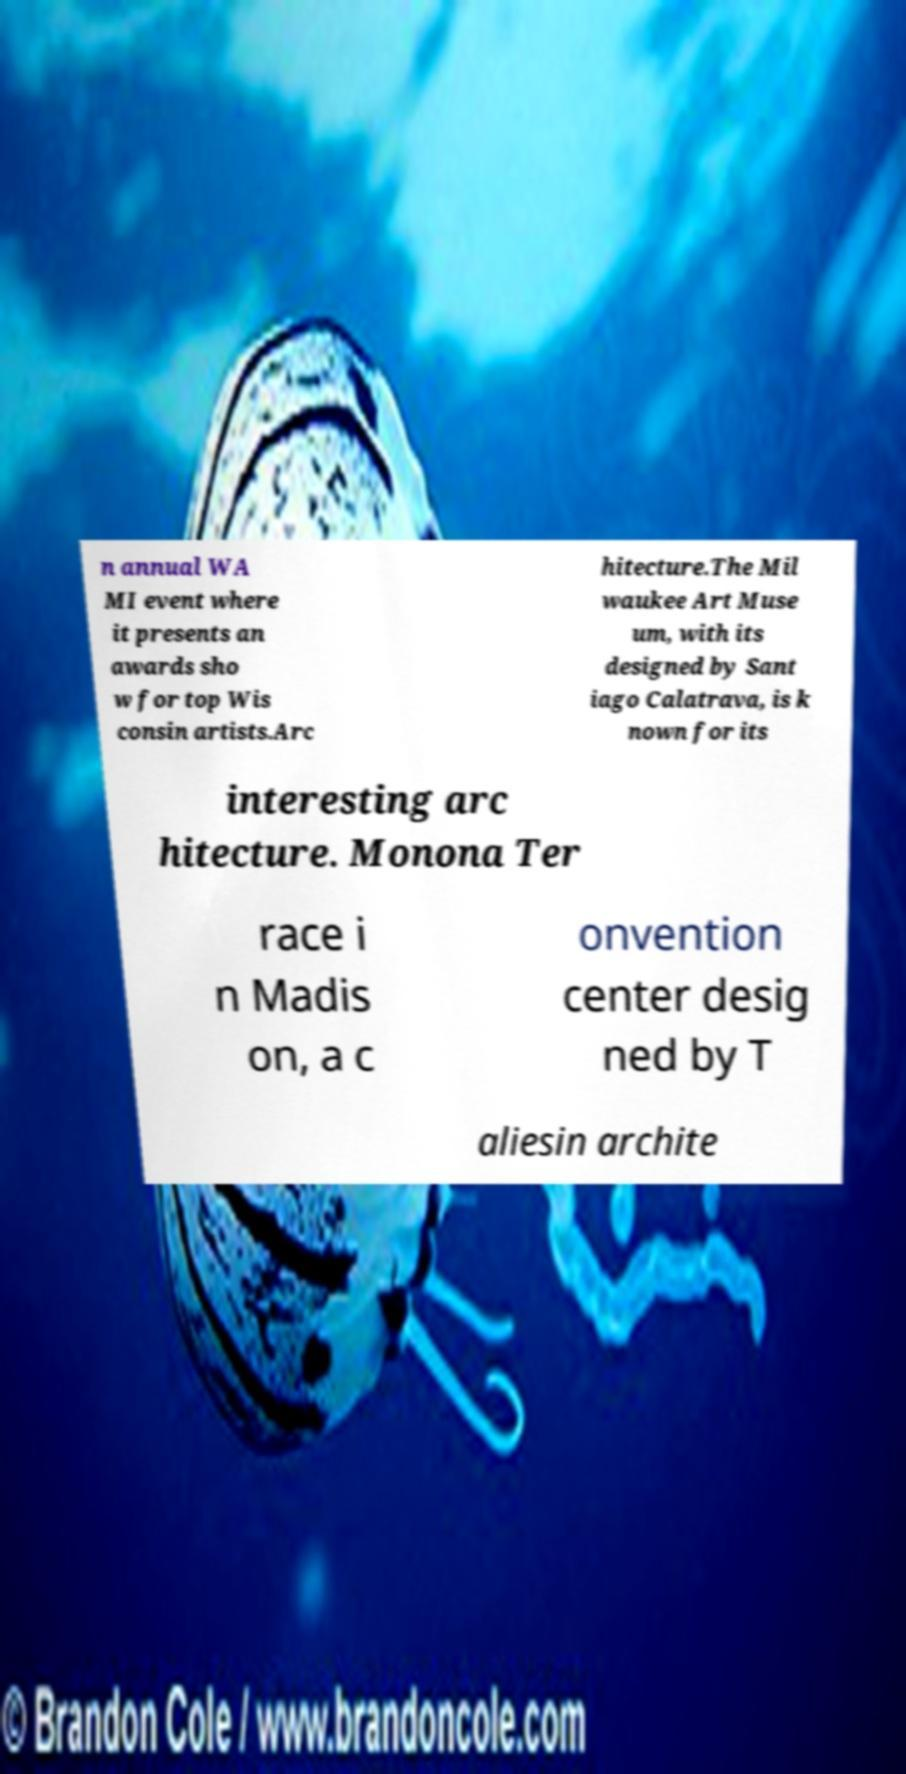There's text embedded in this image that I need extracted. Can you transcribe it verbatim? n annual WA MI event where it presents an awards sho w for top Wis consin artists.Arc hitecture.The Mil waukee Art Muse um, with its designed by Sant iago Calatrava, is k nown for its interesting arc hitecture. Monona Ter race i n Madis on, a c onvention center desig ned by T aliesin archite 